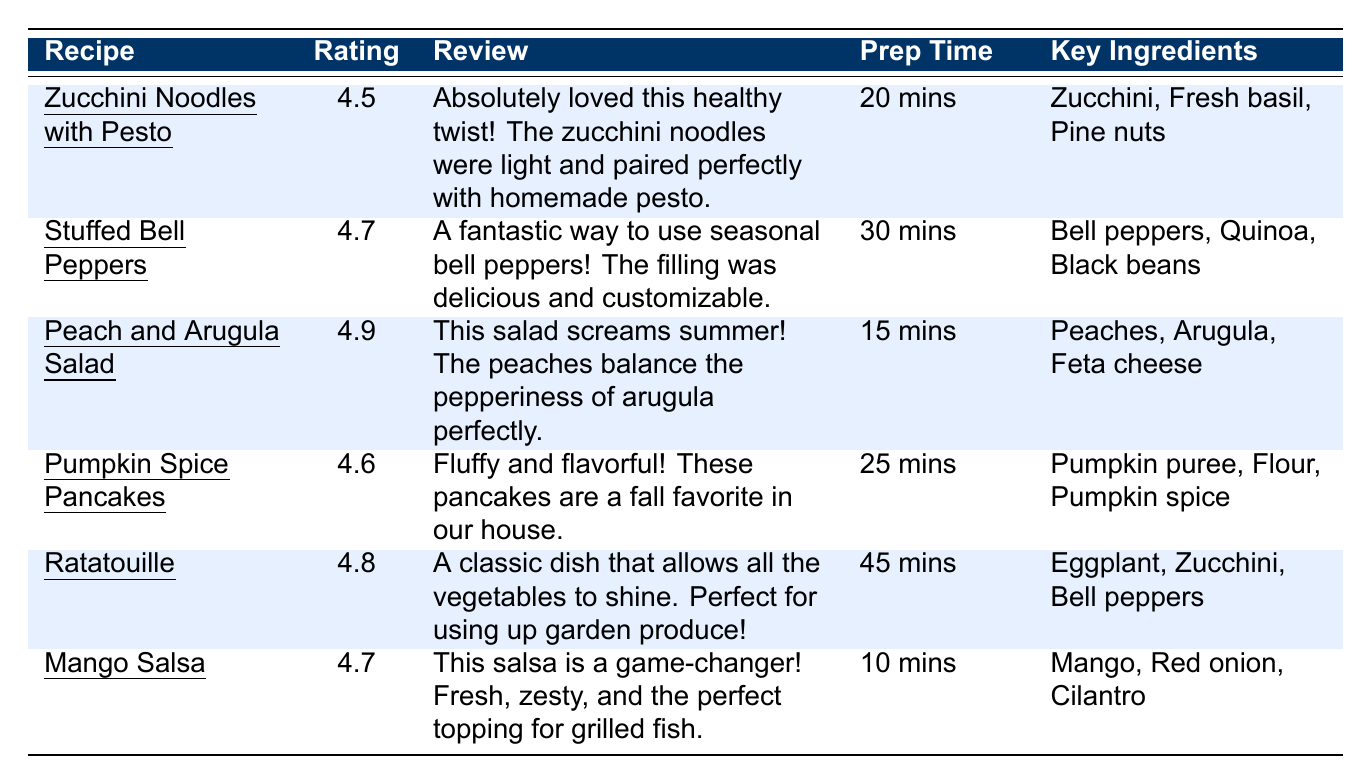What is the highest user rating among the recipes? The highest user rating in the table is for the "Peach and Arugula Salad," which has a rating of 4.9.
Answer: 4.9 Which recipe has the shortest preparation time? "Mango Salsa" has the shortest preparation time of 10 minutes compared to other recipes.
Answer: 10 mins How many recipes received a rating of 4.7 or higher? There are four recipes with a rating of 4.7 or higher: "Stuffed Bell Peppers" (4.7), "Peach and Arugula Salad" (4.9), "Pumpkin Spice Pancakes" (4.6), and "Mango Salsa" (4.7) making a total of 4.
Answer: 4 What ingredients are common in the highest-rated recipe? The highest-rated recipe, "Peach and Arugula Salad," uses Peaches, Arugula, and Feta cheese, which are not used in any other recipes as key ingredients.
Answer: Peaches, Arugula, Feta cheese Who reviewed the "Ratatouille" recipe? The review for "Ratatouille" was made by Lena, as indicated in the user column of the table.
Answer: Lena Are all the recipes listed reviewed by different users? Yes, all six recipes listed are reviewed by different users: Samantha, Kyle, Maria, Steve, Lena, and Brian.
Answer: Yes What is the total number of ingredients used across all recipes? To find the total number of unique ingredients, we list them: Zucchini, Fresh basil, Garlic, Pine nuts, Olive oil, Parmesan cheese, Bell peppers, Quinoa, Black beans, Corn, Cheddar cheese, Peaches, Arugula, Feta cheese, Balsamic vinaigrette, Walnuts, Pumpkin puree, Flour, Eggs, Milk, Pumpkin spice, Maple syrup, Eggplant, Tomatoes, Onions, Herbs de Provence, Mango, Red onion, Cilantro, Lime juice, Jalapeño. This results in 28 unique ingredients.
Answer: 28 How does the average rating of the recipes compare to the average prep time? The average rating is calculated as (4.5 + 4.7 + 4.9 + 4.6 + 4.8 + 4.7) / 6 = 4.63, while the average prep time is (20 + 30 + 15 + 25 + 45 + 10) / 6 = 23.33 minutes. Thus, the average rating is higher than the average prep time.
Answer: The average rating is higher than the average prep time Which recipe offers the best balance of quick prep time and high user rating? "Mango Salsa" has a prep time of only 10 minutes and a user rating of 4.7, offering the best balance of quick prep and high rating in the list.
Answer: Mango Salsa 